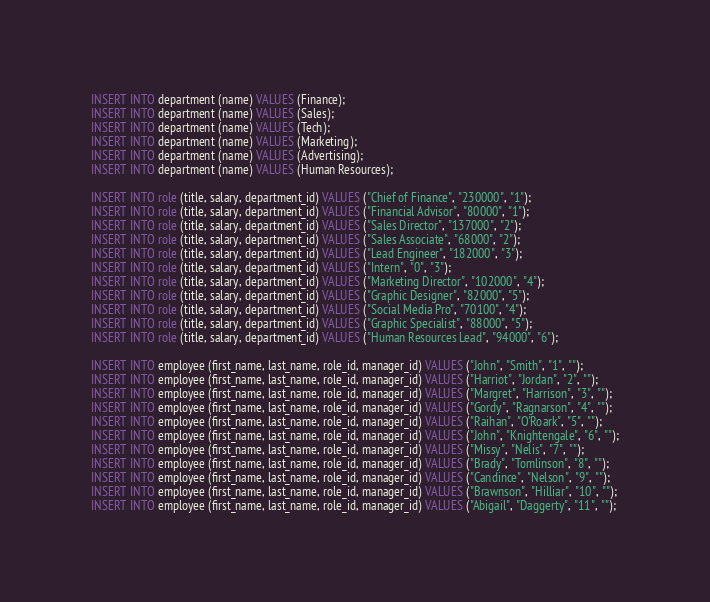Convert code to text. <code><loc_0><loc_0><loc_500><loc_500><_SQL_>INSERT INTO department (name) VALUES (Finance);
INSERT INTO department (name) VALUES (Sales);
INSERT INTO department (name) VALUES (Tech);
INSERT INTO department (name) VALUES (Marketing);
INSERT INTO department (name) VALUES (Advertising);
INSERT INTO department (name) VALUES (Human Resources);

INSERT INTO role (title, salary, department_id) VALUES ("Chief of Finance", "230000", "1");
INSERT INTO role (title, salary, department_id) VALUES ("Financial Advisor", "80000", "1");
INSERT INTO role (title, salary, department_id) VALUES ("Sales Director", "137000", "2");
INSERT INTO role (title, salary, department_id) VALUES ("Sales Associate", "68000", "2");
INSERT INTO role (title, salary, department_id) VALUES ("Lead Engineer", "182000", "3");
INSERT INTO role (title, salary, department_id) VALUES ("Intern", "0", "3");
INSERT INTO role (title, salary, department_id) VALUES ("Marketing Director", "102000", "4");
INSERT INTO role (title, salary, department_id) VALUES ("Graphic Designer", "82000", "5");
INSERT INTO role (title, salary, department_id) VALUES ("Social Media Pro", "70100", "4");
INSERT INTO role (title, salary, department_id) VALUES ("Graphic Specialist", "88000", "5");
INSERT INTO role (title, salary, department_id) VALUES ("Human Resources Lead", "94000", "6");

INSERT INTO employee (first_name, last_name, role_id, manager_id) VALUES ("John", "Smith", "1", "");
INSERT INTO employee (first_name, last_name, role_id, manager_id) VALUES ("Harriot", "Jordan", "2", "");
INSERT INTO employee (first_name, last_name, role_id, manager_id) VALUES ("Margret", "Harrison", "3", "");
INSERT INTO employee (first_name, last_name, role_id, manager_id) VALUES ("Gordy", "Ragnarson", "4", "");
INSERT INTO employee (first_name, last_name, role_id, manager_id) VALUES ("Raihan", "O'Roark", "5", "");
INSERT INTO employee (first_name, last_name, role_id, manager_id) VALUES ("John", "Knightengale", "6", "");
INSERT INTO employee (first_name, last_name, role_id, manager_id) VALUES ("Missy", "Nelis", "7", "");
INSERT INTO employee (first_name, last_name, role_id, manager_id) VALUES ("Brady", "Tomlinson", "8", "");
INSERT INTO employee (first_name, last_name, role_id, manager_id) VALUES ("Candince", "Nelson", "9", "");
INSERT INTO employee (first_name, last_name, role_id, manager_id) VALUES ("Brawnson", "Hilliar", "10", "");
INSERT INTO employee (first_name, last_name, role_id, manager_id) VALUES ("Abigail", "Daggerty", "11", "");
</code> 